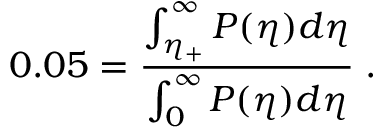<formula> <loc_0><loc_0><loc_500><loc_500>0 . 0 5 = \frac { \int _ { \eta _ { + } } ^ { \infty } P ( \eta ) d \eta } { \int _ { 0 } ^ { \infty } P ( \eta ) d \eta } \, .</formula> 